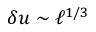Convert formula to latex. <formula><loc_0><loc_0><loc_500><loc_500>\delta u \sim \ell ^ { 1 / 3 }</formula> 